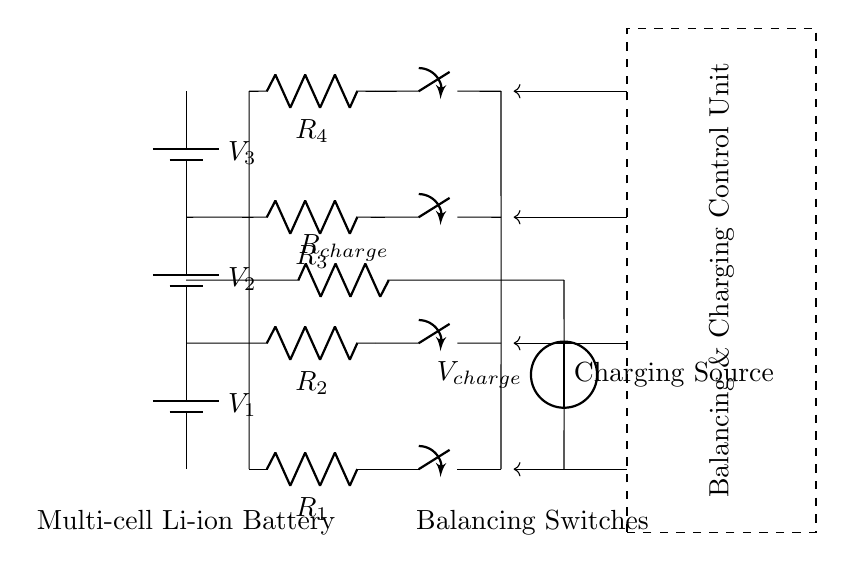What type of battery is shown in the circuit? The circuit diagram features multi-cell lithium-ion batteries, indicated by the battery symbol and the specific labeling.
Answer: Multi-cell lithium-ion How many resistors are present in the circuit? The circuit contains four resistors, as can be identified by the resistor symbols labeled R1, R2, R3, and R4.
Answer: Four What is the purpose of the balancing circuitry? The balancing circuitry, represented by the resistors and switches connected to each battery cell, is used to equalize the charge across the battery cells during the charging process.
Answer: Equalizing charge What is the primary function of the control unit in this circuit? The control unit regulates the charging process and coordinates the balancing of the battery cells, ensuring efficiency and safety during charging.
Answer: Regulation What type of component is used for the power source in this circuit? The charging source in the circuit is represented by a voltage source symbol, indicating it supplies electric potential necessary for charging the battery.
Answer: Voltage source How is the charging current likely controlled in this circuit? The circuit uses a resistor labeled Rcharge in series with the charging voltage source, which helps limit and control the charging current flowing into the battery system.
Answer: Through resistance What happens to the switches in this circuit during charging? The switches connected to each battery cell are closed, allowing current to flow through the resistors and balancing the charging process across the cells.
Answer: They close 